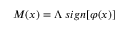<formula> <loc_0><loc_0><loc_500><loc_500>M ( x ) = \Lambda \, s i g n [ \varphi ( x ) ]</formula> 